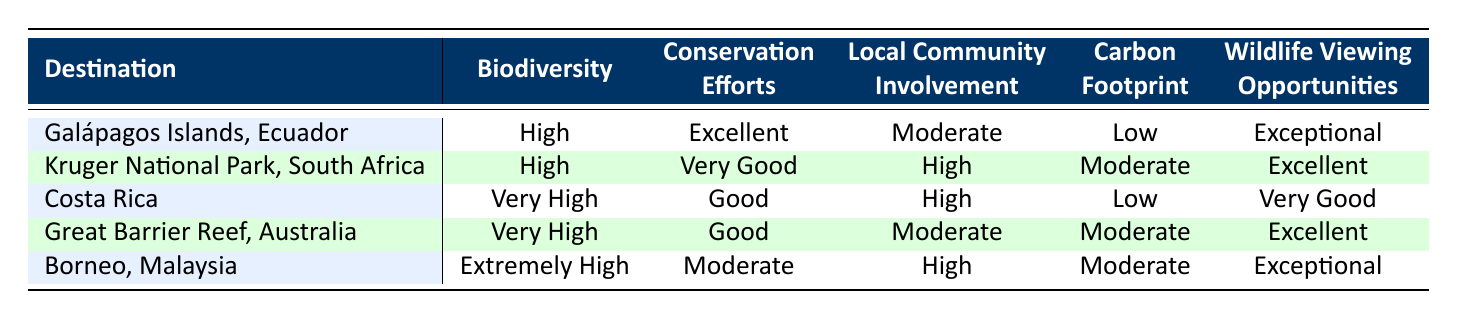What is the biodiversity rating for Borneo, Malaysia? By looking at the row for Borneo, Malaysia, we can find the "Biodiversity" column, which states "Extremely High."
Answer: Extremely High Which destination offers the best conservation efforts? The column for "Conservation Efforts" shows the highest rating is "Excellent," which applies to the Galápagos Islands, Ecuador.
Answer: Galápagos Islands, Ecuador How many destinations have a low carbon footprint? Checking the "Carbon Footprint" column, there are two destinations: Galápagos Islands, Ecuador and Costa Rica, which are rated "Low." Summing these gives us a total of 2 destinations with a low carbon footprint.
Answer: 2 Which destination has both high wildlife viewing opportunities and high local community involvement? Looking at the "Wildlife Viewing Opportunities" and "Local Community Involvement" columns, the destination that meets both criteria with "Excellent" or better for wildlife viewing and "High" for community involvement is Kruger National Park, South Africa.
Answer: Kruger National Park, South Africa Would you say that Great Barrier Reef has better biodiversity than Kruger National Park? "Great Barrier Reef" has a biodiversity rating of "Very High," while "Kruger National Park" has a rating of "High." Since "Very High" is superior to "High," the statement that the Great Barrier Reef has better biodiversity is true.
Answer: Yes What is the average biodiversity rating of all listed destinations? Assigning numerical values: Low (1), Moderate (2), High (3), Very High (4), Extremely High (5). For the destinations, the ratings are: Galápagos Islands (3), Kruger National Park (3), Costa Rica (4), Great Barrier Reef (4), and Borneo (5). The sum is 19, and there are 5 destinations, giving an average of 19/5 = 3.8, which corresponds to "Very High."
Answer: Very High Which destination has the lowest local community involvement? Examining the "Local Community Involvement" column, the lowest rating is "Moderate," which applies to both Galápagos Islands, Ecuador and Great Barrier Reef, Australia.
Answer: Galápagos Islands, Ecuador and Great Barrier Reef, Australia Is there a destination with both a "Very Good" rating in conservation efforts and low carbon footprint? The only destination that meets these criteria is Kruger National Park, South Africa, which has a "Very Good" rating for conservation and "Moderate" for carbon footprint. Therefore, no destination meets both of the specified criteria.
Answer: No 